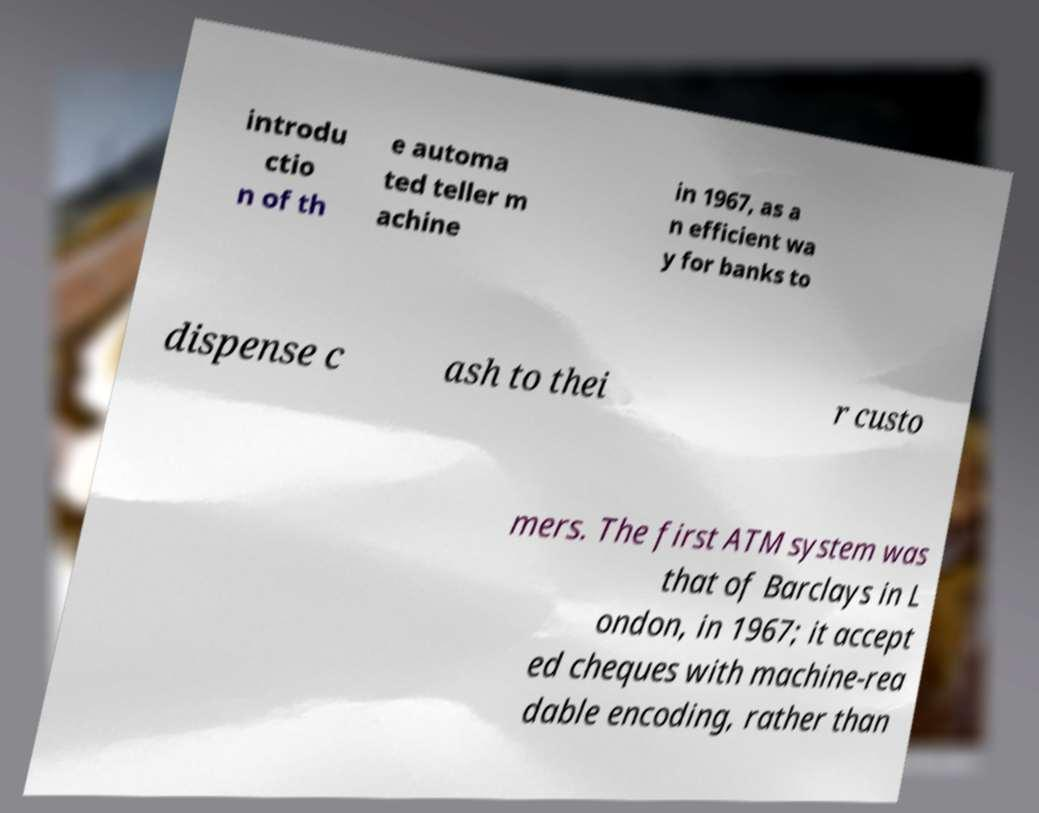Can you accurately transcribe the text from the provided image for me? introdu ctio n of th e automa ted teller m achine in 1967, as a n efficient wa y for banks to dispense c ash to thei r custo mers. The first ATM system was that of Barclays in L ondon, in 1967; it accept ed cheques with machine-rea dable encoding, rather than 